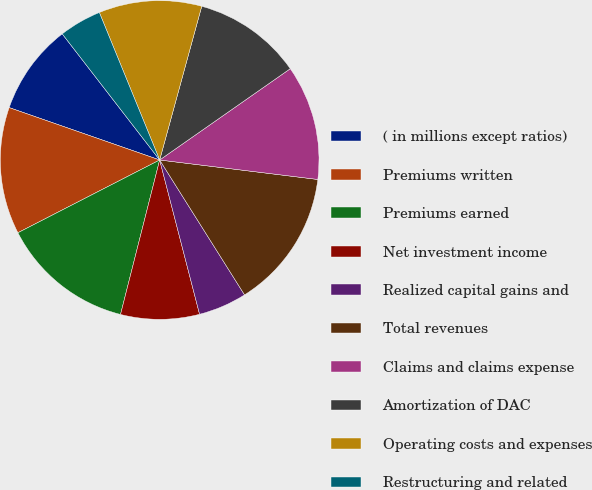Convert chart to OTSL. <chart><loc_0><loc_0><loc_500><loc_500><pie_chart><fcel>( in millions except ratios)<fcel>Premiums written<fcel>Premiums earned<fcel>Net investment income<fcel>Realized capital gains and<fcel>Total revenues<fcel>Claims and claims expense<fcel>Amortization of DAC<fcel>Operating costs and expenses<fcel>Restructuring and related<nl><fcel>9.2%<fcel>12.88%<fcel>13.5%<fcel>7.98%<fcel>4.91%<fcel>14.11%<fcel>11.66%<fcel>11.04%<fcel>10.43%<fcel>4.29%<nl></chart> 